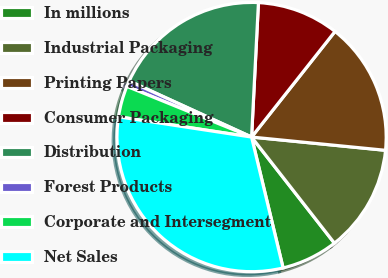Convert chart to OTSL. <chart><loc_0><loc_0><loc_500><loc_500><pie_chart><fcel>In millions<fcel>Industrial Packaging<fcel>Printing Papers<fcel>Consumer Packaging<fcel>Distribution<fcel>Forest Products<fcel>Corporate and Intersegment<fcel>Net Sales<nl><fcel>6.79%<fcel>12.88%<fcel>15.93%<fcel>9.83%<fcel>18.98%<fcel>0.69%<fcel>3.74%<fcel>31.17%<nl></chart> 